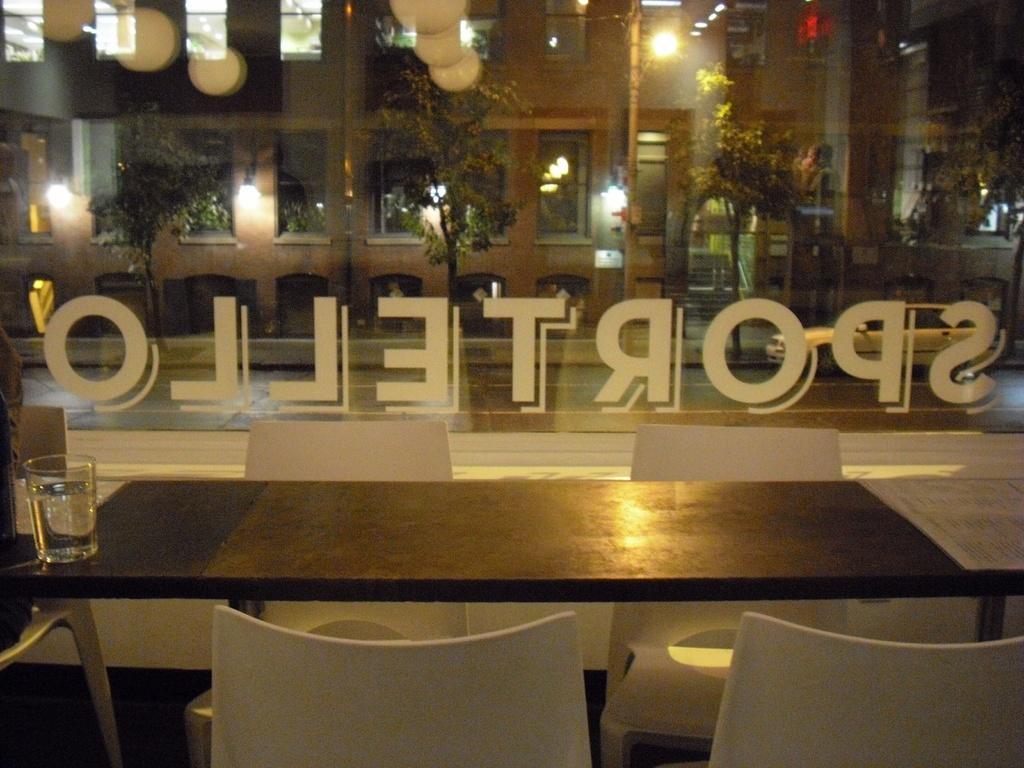Could you give a brief overview of what you see in this image? In the image we can see there is a dining table, there are chairs and there is a glass of water kept on the table. Outside the window there are trees and there is a building. 